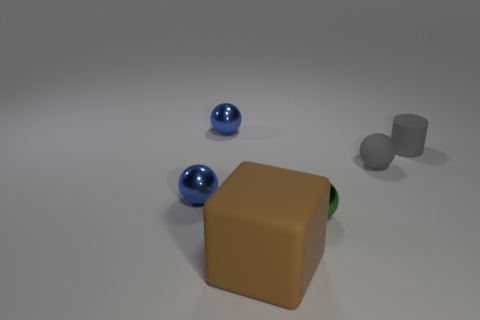Add 2 matte spheres. How many objects exist? 8 Subtract all cylinders. How many objects are left? 5 Subtract all small metallic balls. How many balls are left? 1 Subtract all gray spheres. How many spheres are left? 3 Subtract 3 balls. How many balls are left? 1 Subtract all green cylinders. Subtract all yellow spheres. How many cylinders are left? 1 Subtract all red spheres. How many cyan cubes are left? 0 Subtract all brown things. Subtract all small cylinders. How many objects are left? 4 Add 2 small blue metallic balls. How many small blue metallic balls are left? 4 Add 6 big purple matte balls. How many big purple matte balls exist? 6 